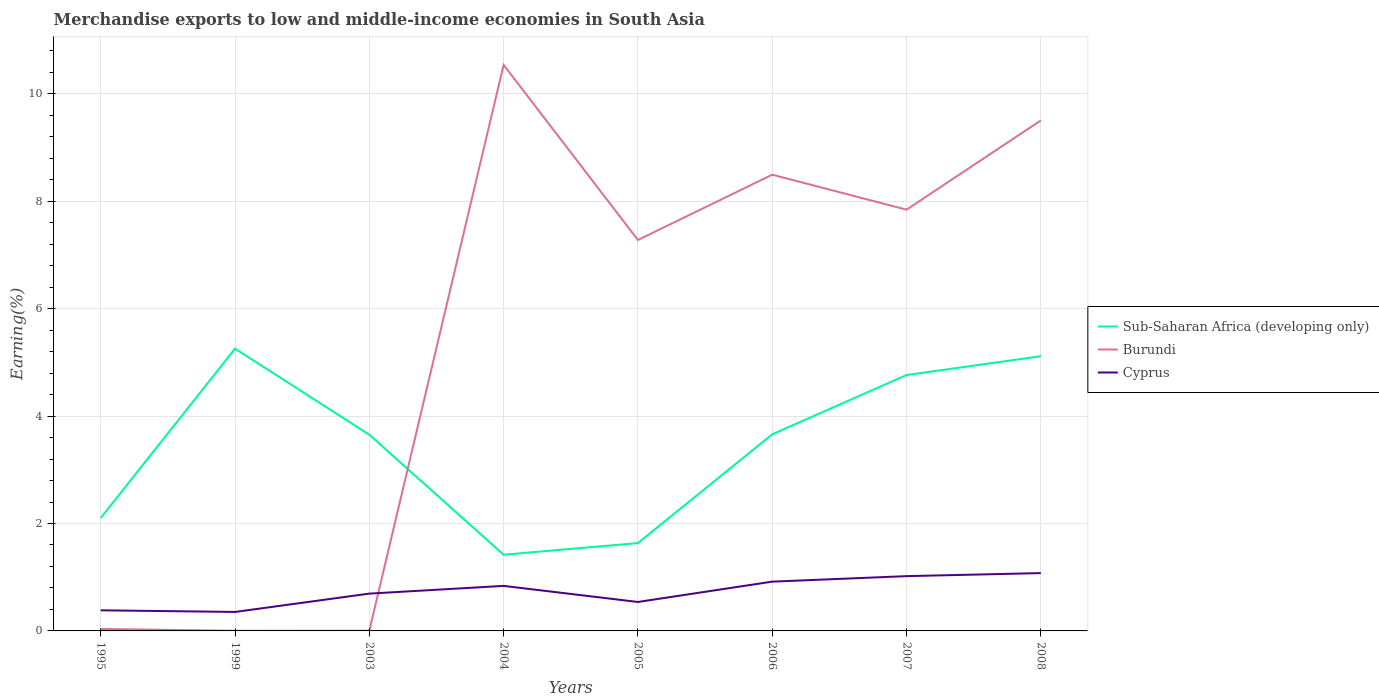How many different coloured lines are there?
Give a very brief answer. 3. Is the number of lines equal to the number of legend labels?
Ensure brevity in your answer.  Yes. Across all years, what is the maximum percentage of amount earned from merchandise exports in Cyprus?
Your answer should be compact. 0.35. In which year was the percentage of amount earned from merchandise exports in Burundi maximum?
Give a very brief answer. 1999. What is the total percentage of amount earned from merchandise exports in Cyprus in the graph?
Your response must be concise. -0.08. What is the difference between the highest and the second highest percentage of amount earned from merchandise exports in Sub-Saharan Africa (developing only)?
Your answer should be very brief. 3.84. How many lines are there?
Give a very brief answer. 3. How many years are there in the graph?
Offer a very short reply. 8. Are the values on the major ticks of Y-axis written in scientific E-notation?
Provide a succinct answer. No. Where does the legend appear in the graph?
Ensure brevity in your answer.  Center right. How many legend labels are there?
Ensure brevity in your answer.  3. How are the legend labels stacked?
Ensure brevity in your answer.  Vertical. What is the title of the graph?
Offer a very short reply. Merchandise exports to low and middle-income economies in South Asia. Does "World" appear as one of the legend labels in the graph?
Your answer should be compact. No. What is the label or title of the X-axis?
Provide a succinct answer. Years. What is the label or title of the Y-axis?
Offer a terse response. Earning(%). What is the Earning(%) in Sub-Saharan Africa (developing only) in 1995?
Your answer should be very brief. 2.1. What is the Earning(%) of Burundi in 1995?
Give a very brief answer. 0.04. What is the Earning(%) in Cyprus in 1995?
Ensure brevity in your answer.  0.38. What is the Earning(%) in Sub-Saharan Africa (developing only) in 1999?
Your response must be concise. 5.26. What is the Earning(%) in Burundi in 1999?
Give a very brief answer. 0. What is the Earning(%) in Cyprus in 1999?
Your answer should be compact. 0.35. What is the Earning(%) in Sub-Saharan Africa (developing only) in 2003?
Offer a terse response. 3.65. What is the Earning(%) of Burundi in 2003?
Give a very brief answer. 0. What is the Earning(%) of Cyprus in 2003?
Provide a short and direct response. 0.69. What is the Earning(%) in Sub-Saharan Africa (developing only) in 2004?
Give a very brief answer. 1.42. What is the Earning(%) of Burundi in 2004?
Keep it short and to the point. 10.54. What is the Earning(%) in Cyprus in 2004?
Your response must be concise. 0.84. What is the Earning(%) of Sub-Saharan Africa (developing only) in 2005?
Provide a short and direct response. 1.64. What is the Earning(%) of Burundi in 2005?
Your response must be concise. 7.28. What is the Earning(%) in Cyprus in 2005?
Your answer should be very brief. 0.54. What is the Earning(%) in Sub-Saharan Africa (developing only) in 2006?
Your response must be concise. 3.66. What is the Earning(%) in Burundi in 2006?
Make the answer very short. 8.49. What is the Earning(%) in Cyprus in 2006?
Your response must be concise. 0.92. What is the Earning(%) in Sub-Saharan Africa (developing only) in 2007?
Your response must be concise. 4.76. What is the Earning(%) of Burundi in 2007?
Offer a very short reply. 7.84. What is the Earning(%) of Cyprus in 2007?
Provide a succinct answer. 1.02. What is the Earning(%) of Sub-Saharan Africa (developing only) in 2008?
Keep it short and to the point. 5.11. What is the Earning(%) of Burundi in 2008?
Provide a short and direct response. 9.5. What is the Earning(%) of Cyprus in 2008?
Keep it short and to the point. 1.08. Across all years, what is the maximum Earning(%) in Sub-Saharan Africa (developing only)?
Provide a succinct answer. 5.26. Across all years, what is the maximum Earning(%) of Burundi?
Keep it short and to the point. 10.54. Across all years, what is the maximum Earning(%) in Cyprus?
Your response must be concise. 1.08. Across all years, what is the minimum Earning(%) of Sub-Saharan Africa (developing only)?
Your answer should be very brief. 1.42. Across all years, what is the minimum Earning(%) of Burundi?
Make the answer very short. 0. Across all years, what is the minimum Earning(%) in Cyprus?
Offer a very short reply. 0.35. What is the total Earning(%) in Sub-Saharan Africa (developing only) in the graph?
Ensure brevity in your answer.  27.6. What is the total Earning(%) of Burundi in the graph?
Keep it short and to the point. 43.7. What is the total Earning(%) of Cyprus in the graph?
Your answer should be compact. 5.82. What is the difference between the Earning(%) of Sub-Saharan Africa (developing only) in 1995 and that in 1999?
Your response must be concise. -3.15. What is the difference between the Earning(%) in Burundi in 1995 and that in 1999?
Make the answer very short. 0.03. What is the difference between the Earning(%) in Cyprus in 1995 and that in 1999?
Provide a short and direct response. 0.03. What is the difference between the Earning(%) of Sub-Saharan Africa (developing only) in 1995 and that in 2003?
Offer a terse response. -1.55. What is the difference between the Earning(%) in Burundi in 1995 and that in 2003?
Provide a short and direct response. 0.03. What is the difference between the Earning(%) of Cyprus in 1995 and that in 2003?
Give a very brief answer. -0.31. What is the difference between the Earning(%) of Sub-Saharan Africa (developing only) in 1995 and that in 2004?
Provide a succinct answer. 0.68. What is the difference between the Earning(%) of Burundi in 1995 and that in 2004?
Make the answer very short. -10.5. What is the difference between the Earning(%) of Cyprus in 1995 and that in 2004?
Your answer should be compact. -0.45. What is the difference between the Earning(%) of Sub-Saharan Africa (developing only) in 1995 and that in 2005?
Make the answer very short. 0.47. What is the difference between the Earning(%) of Burundi in 1995 and that in 2005?
Ensure brevity in your answer.  -7.24. What is the difference between the Earning(%) of Cyprus in 1995 and that in 2005?
Give a very brief answer. -0.16. What is the difference between the Earning(%) of Sub-Saharan Africa (developing only) in 1995 and that in 2006?
Provide a short and direct response. -1.56. What is the difference between the Earning(%) in Burundi in 1995 and that in 2006?
Provide a short and direct response. -8.46. What is the difference between the Earning(%) in Cyprus in 1995 and that in 2006?
Provide a succinct answer. -0.53. What is the difference between the Earning(%) in Sub-Saharan Africa (developing only) in 1995 and that in 2007?
Your answer should be compact. -2.66. What is the difference between the Earning(%) of Burundi in 1995 and that in 2007?
Ensure brevity in your answer.  -7.81. What is the difference between the Earning(%) of Cyprus in 1995 and that in 2007?
Your answer should be very brief. -0.64. What is the difference between the Earning(%) of Sub-Saharan Africa (developing only) in 1995 and that in 2008?
Keep it short and to the point. -3.01. What is the difference between the Earning(%) in Burundi in 1995 and that in 2008?
Your answer should be compact. -9.47. What is the difference between the Earning(%) in Cyprus in 1995 and that in 2008?
Offer a very short reply. -0.69. What is the difference between the Earning(%) in Sub-Saharan Africa (developing only) in 1999 and that in 2003?
Your response must be concise. 1.6. What is the difference between the Earning(%) in Burundi in 1999 and that in 2003?
Offer a terse response. -0. What is the difference between the Earning(%) in Cyprus in 1999 and that in 2003?
Keep it short and to the point. -0.34. What is the difference between the Earning(%) of Sub-Saharan Africa (developing only) in 1999 and that in 2004?
Provide a succinct answer. 3.84. What is the difference between the Earning(%) in Burundi in 1999 and that in 2004?
Your answer should be very brief. -10.54. What is the difference between the Earning(%) of Cyprus in 1999 and that in 2004?
Provide a short and direct response. -0.48. What is the difference between the Earning(%) of Sub-Saharan Africa (developing only) in 1999 and that in 2005?
Your answer should be compact. 3.62. What is the difference between the Earning(%) of Burundi in 1999 and that in 2005?
Provide a short and direct response. -7.28. What is the difference between the Earning(%) in Cyprus in 1999 and that in 2005?
Your answer should be compact. -0.19. What is the difference between the Earning(%) in Sub-Saharan Africa (developing only) in 1999 and that in 2006?
Your answer should be very brief. 1.6. What is the difference between the Earning(%) in Burundi in 1999 and that in 2006?
Provide a short and direct response. -8.49. What is the difference between the Earning(%) in Cyprus in 1999 and that in 2006?
Your response must be concise. -0.56. What is the difference between the Earning(%) of Sub-Saharan Africa (developing only) in 1999 and that in 2007?
Give a very brief answer. 0.49. What is the difference between the Earning(%) in Burundi in 1999 and that in 2007?
Keep it short and to the point. -7.84. What is the difference between the Earning(%) in Cyprus in 1999 and that in 2007?
Offer a very short reply. -0.67. What is the difference between the Earning(%) of Sub-Saharan Africa (developing only) in 1999 and that in 2008?
Provide a short and direct response. 0.14. What is the difference between the Earning(%) of Burundi in 1999 and that in 2008?
Provide a short and direct response. -9.5. What is the difference between the Earning(%) in Cyprus in 1999 and that in 2008?
Provide a succinct answer. -0.72. What is the difference between the Earning(%) of Sub-Saharan Africa (developing only) in 2003 and that in 2004?
Make the answer very short. 2.23. What is the difference between the Earning(%) in Burundi in 2003 and that in 2004?
Give a very brief answer. -10.53. What is the difference between the Earning(%) in Cyprus in 2003 and that in 2004?
Provide a short and direct response. -0.14. What is the difference between the Earning(%) of Sub-Saharan Africa (developing only) in 2003 and that in 2005?
Offer a terse response. 2.02. What is the difference between the Earning(%) in Burundi in 2003 and that in 2005?
Provide a short and direct response. -7.27. What is the difference between the Earning(%) in Cyprus in 2003 and that in 2005?
Offer a terse response. 0.16. What is the difference between the Earning(%) of Sub-Saharan Africa (developing only) in 2003 and that in 2006?
Give a very brief answer. -0.01. What is the difference between the Earning(%) in Burundi in 2003 and that in 2006?
Give a very brief answer. -8.49. What is the difference between the Earning(%) of Cyprus in 2003 and that in 2006?
Your answer should be very brief. -0.22. What is the difference between the Earning(%) of Sub-Saharan Africa (developing only) in 2003 and that in 2007?
Keep it short and to the point. -1.11. What is the difference between the Earning(%) of Burundi in 2003 and that in 2007?
Provide a succinct answer. -7.84. What is the difference between the Earning(%) of Cyprus in 2003 and that in 2007?
Offer a very short reply. -0.33. What is the difference between the Earning(%) of Sub-Saharan Africa (developing only) in 2003 and that in 2008?
Offer a very short reply. -1.46. What is the difference between the Earning(%) of Burundi in 2003 and that in 2008?
Keep it short and to the point. -9.5. What is the difference between the Earning(%) of Cyprus in 2003 and that in 2008?
Make the answer very short. -0.38. What is the difference between the Earning(%) in Sub-Saharan Africa (developing only) in 2004 and that in 2005?
Your answer should be compact. -0.22. What is the difference between the Earning(%) in Burundi in 2004 and that in 2005?
Make the answer very short. 3.26. What is the difference between the Earning(%) in Cyprus in 2004 and that in 2005?
Provide a short and direct response. 0.3. What is the difference between the Earning(%) in Sub-Saharan Africa (developing only) in 2004 and that in 2006?
Your answer should be compact. -2.24. What is the difference between the Earning(%) of Burundi in 2004 and that in 2006?
Make the answer very short. 2.04. What is the difference between the Earning(%) of Cyprus in 2004 and that in 2006?
Offer a terse response. -0.08. What is the difference between the Earning(%) of Sub-Saharan Africa (developing only) in 2004 and that in 2007?
Keep it short and to the point. -3.35. What is the difference between the Earning(%) of Burundi in 2004 and that in 2007?
Ensure brevity in your answer.  2.7. What is the difference between the Earning(%) in Cyprus in 2004 and that in 2007?
Your response must be concise. -0.18. What is the difference between the Earning(%) in Sub-Saharan Africa (developing only) in 2004 and that in 2008?
Your answer should be compact. -3.7. What is the difference between the Earning(%) of Burundi in 2004 and that in 2008?
Your response must be concise. 1.03. What is the difference between the Earning(%) in Cyprus in 2004 and that in 2008?
Make the answer very short. -0.24. What is the difference between the Earning(%) in Sub-Saharan Africa (developing only) in 2005 and that in 2006?
Your answer should be compact. -2.02. What is the difference between the Earning(%) in Burundi in 2005 and that in 2006?
Make the answer very short. -1.22. What is the difference between the Earning(%) in Cyprus in 2005 and that in 2006?
Make the answer very short. -0.38. What is the difference between the Earning(%) of Sub-Saharan Africa (developing only) in 2005 and that in 2007?
Provide a succinct answer. -3.13. What is the difference between the Earning(%) in Burundi in 2005 and that in 2007?
Keep it short and to the point. -0.56. What is the difference between the Earning(%) in Cyprus in 2005 and that in 2007?
Provide a succinct answer. -0.48. What is the difference between the Earning(%) in Sub-Saharan Africa (developing only) in 2005 and that in 2008?
Keep it short and to the point. -3.48. What is the difference between the Earning(%) in Burundi in 2005 and that in 2008?
Offer a very short reply. -2.23. What is the difference between the Earning(%) of Cyprus in 2005 and that in 2008?
Ensure brevity in your answer.  -0.54. What is the difference between the Earning(%) of Sub-Saharan Africa (developing only) in 2006 and that in 2007?
Your answer should be compact. -1.1. What is the difference between the Earning(%) of Burundi in 2006 and that in 2007?
Your response must be concise. 0.65. What is the difference between the Earning(%) in Cyprus in 2006 and that in 2007?
Make the answer very short. -0.1. What is the difference between the Earning(%) of Sub-Saharan Africa (developing only) in 2006 and that in 2008?
Offer a very short reply. -1.45. What is the difference between the Earning(%) of Burundi in 2006 and that in 2008?
Provide a succinct answer. -1.01. What is the difference between the Earning(%) in Cyprus in 2006 and that in 2008?
Your response must be concise. -0.16. What is the difference between the Earning(%) in Sub-Saharan Africa (developing only) in 2007 and that in 2008?
Your answer should be compact. -0.35. What is the difference between the Earning(%) in Burundi in 2007 and that in 2008?
Your response must be concise. -1.66. What is the difference between the Earning(%) in Cyprus in 2007 and that in 2008?
Ensure brevity in your answer.  -0.06. What is the difference between the Earning(%) of Sub-Saharan Africa (developing only) in 1995 and the Earning(%) of Burundi in 1999?
Offer a very short reply. 2.1. What is the difference between the Earning(%) in Sub-Saharan Africa (developing only) in 1995 and the Earning(%) in Cyprus in 1999?
Provide a succinct answer. 1.75. What is the difference between the Earning(%) of Burundi in 1995 and the Earning(%) of Cyprus in 1999?
Ensure brevity in your answer.  -0.32. What is the difference between the Earning(%) of Sub-Saharan Africa (developing only) in 1995 and the Earning(%) of Burundi in 2003?
Your response must be concise. 2.1. What is the difference between the Earning(%) of Sub-Saharan Africa (developing only) in 1995 and the Earning(%) of Cyprus in 2003?
Your answer should be compact. 1.41. What is the difference between the Earning(%) of Burundi in 1995 and the Earning(%) of Cyprus in 2003?
Offer a very short reply. -0.66. What is the difference between the Earning(%) of Sub-Saharan Africa (developing only) in 1995 and the Earning(%) of Burundi in 2004?
Provide a succinct answer. -8.44. What is the difference between the Earning(%) in Sub-Saharan Africa (developing only) in 1995 and the Earning(%) in Cyprus in 2004?
Your answer should be very brief. 1.26. What is the difference between the Earning(%) of Burundi in 1995 and the Earning(%) of Cyprus in 2004?
Your answer should be very brief. -0.8. What is the difference between the Earning(%) of Sub-Saharan Africa (developing only) in 1995 and the Earning(%) of Burundi in 2005?
Offer a very short reply. -5.18. What is the difference between the Earning(%) of Sub-Saharan Africa (developing only) in 1995 and the Earning(%) of Cyprus in 2005?
Offer a terse response. 1.56. What is the difference between the Earning(%) in Burundi in 1995 and the Earning(%) in Cyprus in 2005?
Keep it short and to the point. -0.5. What is the difference between the Earning(%) of Sub-Saharan Africa (developing only) in 1995 and the Earning(%) of Burundi in 2006?
Give a very brief answer. -6.39. What is the difference between the Earning(%) of Sub-Saharan Africa (developing only) in 1995 and the Earning(%) of Cyprus in 2006?
Your answer should be compact. 1.18. What is the difference between the Earning(%) in Burundi in 1995 and the Earning(%) in Cyprus in 2006?
Keep it short and to the point. -0.88. What is the difference between the Earning(%) of Sub-Saharan Africa (developing only) in 1995 and the Earning(%) of Burundi in 2007?
Offer a terse response. -5.74. What is the difference between the Earning(%) in Sub-Saharan Africa (developing only) in 1995 and the Earning(%) in Cyprus in 2007?
Your answer should be very brief. 1.08. What is the difference between the Earning(%) in Burundi in 1995 and the Earning(%) in Cyprus in 2007?
Keep it short and to the point. -0.98. What is the difference between the Earning(%) of Sub-Saharan Africa (developing only) in 1995 and the Earning(%) of Burundi in 2008?
Offer a very short reply. -7.4. What is the difference between the Earning(%) of Sub-Saharan Africa (developing only) in 1995 and the Earning(%) of Cyprus in 2008?
Your response must be concise. 1.03. What is the difference between the Earning(%) in Burundi in 1995 and the Earning(%) in Cyprus in 2008?
Give a very brief answer. -1.04. What is the difference between the Earning(%) of Sub-Saharan Africa (developing only) in 1999 and the Earning(%) of Burundi in 2003?
Give a very brief answer. 5.25. What is the difference between the Earning(%) of Sub-Saharan Africa (developing only) in 1999 and the Earning(%) of Cyprus in 2003?
Offer a very short reply. 4.56. What is the difference between the Earning(%) in Burundi in 1999 and the Earning(%) in Cyprus in 2003?
Offer a very short reply. -0.69. What is the difference between the Earning(%) in Sub-Saharan Africa (developing only) in 1999 and the Earning(%) in Burundi in 2004?
Give a very brief answer. -5.28. What is the difference between the Earning(%) of Sub-Saharan Africa (developing only) in 1999 and the Earning(%) of Cyprus in 2004?
Offer a terse response. 4.42. What is the difference between the Earning(%) of Burundi in 1999 and the Earning(%) of Cyprus in 2004?
Offer a terse response. -0.84. What is the difference between the Earning(%) of Sub-Saharan Africa (developing only) in 1999 and the Earning(%) of Burundi in 2005?
Provide a short and direct response. -2.02. What is the difference between the Earning(%) in Sub-Saharan Africa (developing only) in 1999 and the Earning(%) in Cyprus in 2005?
Provide a short and direct response. 4.72. What is the difference between the Earning(%) in Burundi in 1999 and the Earning(%) in Cyprus in 2005?
Offer a terse response. -0.54. What is the difference between the Earning(%) of Sub-Saharan Africa (developing only) in 1999 and the Earning(%) of Burundi in 2006?
Provide a succinct answer. -3.24. What is the difference between the Earning(%) of Sub-Saharan Africa (developing only) in 1999 and the Earning(%) of Cyprus in 2006?
Ensure brevity in your answer.  4.34. What is the difference between the Earning(%) of Burundi in 1999 and the Earning(%) of Cyprus in 2006?
Give a very brief answer. -0.91. What is the difference between the Earning(%) of Sub-Saharan Africa (developing only) in 1999 and the Earning(%) of Burundi in 2007?
Provide a succinct answer. -2.59. What is the difference between the Earning(%) in Sub-Saharan Africa (developing only) in 1999 and the Earning(%) in Cyprus in 2007?
Provide a short and direct response. 4.24. What is the difference between the Earning(%) in Burundi in 1999 and the Earning(%) in Cyprus in 2007?
Ensure brevity in your answer.  -1.02. What is the difference between the Earning(%) in Sub-Saharan Africa (developing only) in 1999 and the Earning(%) in Burundi in 2008?
Provide a short and direct response. -4.25. What is the difference between the Earning(%) of Sub-Saharan Africa (developing only) in 1999 and the Earning(%) of Cyprus in 2008?
Ensure brevity in your answer.  4.18. What is the difference between the Earning(%) of Burundi in 1999 and the Earning(%) of Cyprus in 2008?
Provide a short and direct response. -1.07. What is the difference between the Earning(%) of Sub-Saharan Africa (developing only) in 2003 and the Earning(%) of Burundi in 2004?
Your answer should be compact. -6.89. What is the difference between the Earning(%) in Sub-Saharan Africa (developing only) in 2003 and the Earning(%) in Cyprus in 2004?
Provide a short and direct response. 2.81. What is the difference between the Earning(%) in Burundi in 2003 and the Earning(%) in Cyprus in 2004?
Your response must be concise. -0.83. What is the difference between the Earning(%) in Sub-Saharan Africa (developing only) in 2003 and the Earning(%) in Burundi in 2005?
Offer a terse response. -3.63. What is the difference between the Earning(%) of Sub-Saharan Africa (developing only) in 2003 and the Earning(%) of Cyprus in 2005?
Ensure brevity in your answer.  3.11. What is the difference between the Earning(%) in Burundi in 2003 and the Earning(%) in Cyprus in 2005?
Your answer should be compact. -0.53. What is the difference between the Earning(%) of Sub-Saharan Africa (developing only) in 2003 and the Earning(%) of Burundi in 2006?
Ensure brevity in your answer.  -4.84. What is the difference between the Earning(%) in Sub-Saharan Africa (developing only) in 2003 and the Earning(%) in Cyprus in 2006?
Your response must be concise. 2.73. What is the difference between the Earning(%) in Burundi in 2003 and the Earning(%) in Cyprus in 2006?
Offer a terse response. -0.91. What is the difference between the Earning(%) in Sub-Saharan Africa (developing only) in 2003 and the Earning(%) in Burundi in 2007?
Provide a succinct answer. -4.19. What is the difference between the Earning(%) of Sub-Saharan Africa (developing only) in 2003 and the Earning(%) of Cyprus in 2007?
Keep it short and to the point. 2.63. What is the difference between the Earning(%) of Burundi in 2003 and the Earning(%) of Cyprus in 2007?
Your response must be concise. -1.02. What is the difference between the Earning(%) in Sub-Saharan Africa (developing only) in 2003 and the Earning(%) in Burundi in 2008?
Ensure brevity in your answer.  -5.85. What is the difference between the Earning(%) in Sub-Saharan Africa (developing only) in 2003 and the Earning(%) in Cyprus in 2008?
Provide a succinct answer. 2.58. What is the difference between the Earning(%) in Burundi in 2003 and the Earning(%) in Cyprus in 2008?
Your answer should be compact. -1.07. What is the difference between the Earning(%) of Sub-Saharan Africa (developing only) in 2004 and the Earning(%) of Burundi in 2005?
Give a very brief answer. -5.86. What is the difference between the Earning(%) in Sub-Saharan Africa (developing only) in 2004 and the Earning(%) in Cyprus in 2005?
Your response must be concise. 0.88. What is the difference between the Earning(%) of Burundi in 2004 and the Earning(%) of Cyprus in 2005?
Provide a succinct answer. 10. What is the difference between the Earning(%) in Sub-Saharan Africa (developing only) in 2004 and the Earning(%) in Burundi in 2006?
Provide a short and direct response. -7.08. What is the difference between the Earning(%) of Sub-Saharan Africa (developing only) in 2004 and the Earning(%) of Cyprus in 2006?
Offer a terse response. 0.5. What is the difference between the Earning(%) of Burundi in 2004 and the Earning(%) of Cyprus in 2006?
Your response must be concise. 9.62. What is the difference between the Earning(%) of Sub-Saharan Africa (developing only) in 2004 and the Earning(%) of Burundi in 2007?
Keep it short and to the point. -6.42. What is the difference between the Earning(%) of Sub-Saharan Africa (developing only) in 2004 and the Earning(%) of Cyprus in 2007?
Offer a very short reply. 0.4. What is the difference between the Earning(%) of Burundi in 2004 and the Earning(%) of Cyprus in 2007?
Offer a terse response. 9.52. What is the difference between the Earning(%) of Sub-Saharan Africa (developing only) in 2004 and the Earning(%) of Burundi in 2008?
Your answer should be very brief. -8.09. What is the difference between the Earning(%) of Sub-Saharan Africa (developing only) in 2004 and the Earning(%) of Cyprus in 2008?
Your response must be concise. 0.34. What is the difference between the Earning(%) of Burundi in 2004 and the Earning(%) of Cyprus in 2008?
Offer a very short reply. 9.46. What is the difference between the Earning(%) of Sub-Saharan Africa (developing only) in 2005 and the Earning(%) of Burundi in 2006?
Provide a short and direct response. -6.86. What is the difference between the Earning(%) in Sub-Saharan Africa (developing only) in 2005 and the Earning(%) in Cyprus in 2006?
Ensure brevity in your answer.  0.72. What is the difference between the Earning(%) of Burundi in 2005 and the Earning(%) of Cyprus in 2006?
Offer a very short reply. 6.36. What is the difference between the Earning(%) of Sub-Saharan Africa (developing only) in 2005 and the Earning(%) of Burundi in 2007?
Your answer should be very brief. -6.21. What is the difference between the Earning(%) in Sub-Saharan Africa (developing only) in 2005 and the Earning(%) in Cyprus in 2007?
Offer a terse response. 0.62. What is the difference between the Earning(%) in Burundi in 2005 and the Earning(%) in Cyprus in 2007?
Offer a very short reply. 6.26. What is the difference between the Earning(%) of Sub-Saharan Africa (developing only) in 2005 and the Earning(%) of Burundi in 2008?
Provide a short and direct response. -7.87. What is the difference between the Earning(%) in Sub-Saharan Africa (developing only) in 2005 and the Earning(%) in Cyprus in 2008?
Offer a very short reply. 0.56. What is the difference between the Earning(%) in Burundi in 2005 and the Earning(%) in Cyprus in 2008?
Give a very brief answer. 6.2. What is the difference between the Earning(%) in Sub-Saharan Africa (developing only) in 2006 and the Earning(%) in Burundi in 2007?
Your answer should be very brief. -4.18. What is the difference between the Earning(%) in Sub-Saharan Africa (developing only) in 2006 and the Earning(%) in Cyprus in 2007?
Provide a succinct answer. 2.64. What is the difference between the Earning(%) in Burundi in 2006 and the Earning(%) in Cyprus in 2007?
Your answer should be compact. 7.47. What is the difference between the Earning(%) in Sub-Saharan Africa (developing only) in 2006 and the Earning(%) in Burundi in 2008?
Your answer should be compact. -5.84. What is the difference between the Earning(%) in Sub-Saharan Africa (developing only) in 2006 and the Earning(%) in Cyprus in 2008?
Provide a succinct answer. 2.58. What is the difference between the Earning(%) of Burundi in 2006 and the Earning(%) of Cyprus in 2008?
Your response must be concise. 7.42. What is the difference between the Earning(%) in Sub-Saharan Africa (developing only) in 2007 and the Earning(%) in Burundi in 2008?
Your answer should be very brief. -4.74. What is the difference between the Earning(%) in Sub-Saharan Africa (developing only) in 2007 and the Earning(%) in Cyprus in 2008?
Give a very brief answer. 3.69. What is the difference between the Earning(%) of Burundi in 2007 and the Earning(%) of Cyprus in 2008?
Ensure brevity in your answer.  6.77. What is the average Earning(%) of Sub-Saharan Africa (developing only) per year?
Give a very brief answer. 3.45. What is the average Earning(%) in Burundi per year?
Offer a terse response. 5.46. What is the average Earning(%) of Cyprus per year?
Provide a short and direct response. 0.73. In the year 1995, what is the difference between the Earning(%) in Sub-Saharan Africa (developing only) and Earning(%) in Burundi?
Offer a terse response. 2.07. In the year 1995, what is the difference between the Earning(%) of Sub-Saharan Africa (developing only) and Earning(%) of Cyprus?
Offer a terse response. 1.72. In the year 1995, what is the difference between the Earning(%) in Burundi and Earning(%) in Cyprus?
Your answer should be very brief. -0.35. In the year 1999, what is the difference between the Earning(%) in Sub-Saharan Africa (developing only) and Earning(%) in Burundi?
Offer a terse response. 5.25. In the year 1999, what is the difference between the Earning(%) in Sub-Saharan Africa (developing only) and Earning(%) in Cyprus?
Your response must be concise. 4.9. In the year 1999, what is the difference between the Earning(%) in Burundi and Earning(%) in Cyprus?
Offer a terse response. -0.35. In the year 2003, what is the difference between the Earning(%) in Sub-Saharan Africa (developing only) and Earning(%) in Burundi?
Provide a short and direct response. 3.65. In the year 2003, what is the difference between the Earning(%) of Sub-Saharan Africa (developing only) and Earning(%) of Cyprus?
Your answer should be compact. 2.96. In the year 2003, what is the difference between the Earning(%) of Burundi and Earning(%) of Cyprus?
Keep it short and to the point. -0.69. In the year 2004, what is the difference between the Earning(%) of Sub-Saharan Africa (developing only) and Earning(%) of Burundi?
Keep it short and to the point. -9.12. In the year 2004, what is the difference between the Earning(%) of Sub-Saharan Africa (developing only) and Earning(%) of Cyprus?
Provide a succinct answer. 0.58. In the year 2004, what is the difference between the Earning(%) in Burundi and Earning(%) in Cyprus?
Provide a succinct answer. 9.7. In the year 2005, what is the difference between the Earning(%) of Sub-Saharan Africa (developing only) and Earning(%) of Burundi?
Make the answer very short. -5.64. In the year 2005, what is the difference between the Earning(%) of Sub-Saharan Africa (developing only) and Earning(%) of Cyprus?
Offer a very short reply. 1.1. In the year 2005, what is the difference between the Earning(%) of Burundi and Earning(%) of Cyprus?
Ensure brevity in your answer.  6.74. In the year 2006, what is the difference between the Earning(%) of Sub-Saharan Africa (developing only) and Earning(%) of Burundi?
Offer a terse response. -4.83. In the year 2006, what is the difference between the Earning(%) in Sub-Saharan Africa (developing only) and Earning(%) in Cyprus?
Your answer should be compact. 2.74. In the year 2006, what is the difference between the Earning(%) in Burundi and Earning(%) in Cyprus?
Your answer should be compact. 7.58. In the year 2007, what is the difference between the Earning(%) of Sub-Saharan Africa (developing only) and Earning(%) of Burundi?
Your response must be concise. -3.08. In the year 2007, what is the difference between the Earning(%) of Sub-Saharan Africa (developing only) and Earning(%) of Cyprus?
Keep it short and to the point. 3.74. In the year 2007, what is the difference between the Earning(%) of Burundi and Earning(%) of Cyprus?
Your answer should be compact. 6.82. In the year 2008, what is the difference between the Earning(%) of Sub-Saharan Africa (developing only) and Earning(%) of Burundi?
Provide a succinct answer. -4.39. In the year 2008, what is the difference between the Earning(%) in Sub-Saharan Africa (developing only) and Earning(%) in Cyprus?
Give a very brief answer. 4.04. In the year 2008, what is the difference between the Earning(%) of Burundi and Earning(%) of Cyprus?
Ensure brevity in your answer.  8.43. What is the ratio of the Earning(%) in Burundi in 1995 to that in 1999?
Give a very brief answer. 14.3. What is the ratio of the Earning(%) of Cyprus in 1995 to that in 1999?
Give a very brief answer. 1.09. What is the ratio of the Earning(%) of Sub-Saharan Africa (developing only) in 1995 to that in 2003?
Make the answer very short. 0.58. What is the ratio of the Earning(%) of Burundi in 1995 to that in 2003?
Your answer should be compact. 8.83. What is the ratio of the Earning(%) of Cyprus in 1995 to that in 2003?
Ensure brevity in your answer.  0.55. What is the ratio of the Earning(%) in Sub-Saharan Africa (developing only) in 1995 to that in 2004?
Your response must be concise. 1.48. What is the ratio of the Earning(%) in Burundi in 1995 to that in 2004?
Give a very brief answer. 0. What is the ratio of the Earning(%) of Cyprus in 1995 to that in 2004?
Provide a succinct answer. 0.46. What is the ratio of the Earning(%) of Sub-Saharan Africa (developing only) in 1995 to that in 2005?
Ensure brevity in your answer.  1.29. What is the ratio of the Earning(%) in Burundi in 1995 to that in 2005?
Offer a very short reply. 0.01. What is the ratio of the Earning(%) of Cyprus in 1995 to that in 2005?
Provide a succinct answer. 0.71. What is the ratio of the Earning(%) of Sub-Saharan Africa (developing only) in 1995 to that in 2006?
Keep it short and to the point. 0.57. What is the ratio of the Earning(%) in Burundi in 1995 to that in 2006?
Give a very brief answer. 0. What is the ratio of the Earning(%) of Cyprus in 1995 to that in 2006?
Offer a very short reply. 0.42. What is the ratio of the Earning(%) in Sub-Saharan Africa (developing only) in 1995 to that in 2007?
Your answer should be very brief. 0.44. What is the ratio of the Earning(%) in Burundi in 1995 to that in 2007?
Your answer should be very brief. 0. What is the ratio of the Earning(%) in Cyprus in 1995 to that in 2007?
Your response must be concise. 0.38. What is the ratio of the Earning(%) of Sub-Saharan Africa (developing only) in 1995 to that in 2008?
Offer a terse response. 0.41. What is the ratio of the Earning(%) in Burundi in 1995 to that in 2008?
Offer a very short reply. 0. What is the ratio of the Earning(%) in Cyprus in 1995 to that in 2008?
Offer a terse response. 0.36. What is the ratio of the Earning(%) in Sub-Saharan Africa (developing only) in 1999 to that in 2003?
Keep it short and to the point. 1.44. What is the ratio of the Earning(%) in Burundi in 1999 to that in 2003?
Ensure brevity in your answer.  0.62. What is the ratio of the Earning(%) of Cyprus in 1999 to that in 2003?
Make the answer very short. 0.51. What is the ratio of the Earning(%) in Sub-Saharan Africa (developing only) in 1999 to that in 2004?
Your answer should be very brief. 3.7. What is the ratio of the Earning(%) of Cyprus in 1999 to that in 2004?
Keep it short and to the point. 0.42. What is the ratio of the Earning(%) in Sub-Saharan Africa (developing only) in 1999 to that in 2005?
Offer a very short reply. 3.21. What is the ratio of the Earning(%) in Cyprus in 1999 to that in 2005?
Ensure brevity in your answer.  0.66. What is the ratio of the Earning(%) of Sub-Saharan Africa (developing only) in 1999 to that in 2006?
Your response must be concise. 1.44. What is the ratio of the Earning(%) in Burundi in 1999 to that in 2006?
Make the answer very short. 0. What is the ratio of the Earning(%) in Cyprus in 1999 to that in 2006?
Offer a terse response. 0.39. What is the ratio of the Earning(%) in Sub-Saharan Africa (developing only) in 1999 to that in 2007?
Offer a terse response. 1.1. What is the ratio of the Earning(%) of Cyprus in 1999 to that in 2007?
Your response must be concise. 0.35. What is the ratio of the Earning(%) in Sub-Saharan Africa (developing only) in 1999 to that in 2008?
Offer a very short reply. 1.03. What is the ratio of the Earning(%) of Burundi in 1999 to that in 2008?
Make the answer very short. 0. What is the ratio of the Earning(%) in Cyprus in 1999 to that in 2008?
Offer a very short reply. 0.33. What is the ratio of the Earning(%) of Sub-Saharan Africa (developing only) in 2003 to that in 2004?
Provide a short and direct response. 2.57. What is the ratio of the Earning(%) of Cyprus in 2003 to that in 2004?
Provide a succinct answer. 0.83. What is the ratio of the Earning(%) of Sub-Saharan Africa (developing only) in 2003 to that in 2005?
Provide a succinct answer. 2.23. What is the ratio of the Earning(%) of Burundi in 2003 to that in 2005?
Your answer should be very brief. 0. What is the ratio of the Earning(%) of Cyprus in 2003 to that in 2005?
Provide a succinct answer. 1.29. What is the ratio of the Earning(%) of Cyprus in 2003 to that in 2006?
Offer a terse response. 0.76. What is the ratio of the Earning(%) in Sub-Saharan Africa (developing only) in 2003 to that in 2007?
Your answer should be very brief. 0.77. What is the ratio of the Earning(%) of Burundi in 2003 to that in 2007?
Ensure brevity in your answer.  0. What is the ratio of the Earning(%) of Cyprus in 2003 to that in 2007?
Keep it short and to the point. 0.68. What is the ratio of the Earning(%) of Sub-Saharan Africa (developing only) in 2003 to that in 2008?
Your answer should be compact. 0.71. What is the ratio of the Earning(%) in Burundi in 2003 to that in 2008?
Keep it short and to the point. 0. What is the ratio of the Earning(%) in Cyprus in 2003 to that in 2008?
Keep it short and to the point. 0.65. What is the ratio of the Earning(%) in Sub-Saharan Africa (developing only) in 2004 to that in 2005?
Offer a terse response. 0.87. What is the ratio of the Earning(%) in Burundi in 2004 to that in 2005?
Offer a very short reply. 1.45. What is the ratio of the Earning(%) in Cyprus in 2004 to that in 2005?
Offer a very short reply. 1.56. What is the ratio of the Earning(%) of Sub-Saharan Africa (developing only) in 2004 to that in 2006?
Give a very brief answer. 0.39. What is the ratio of the Earning(%) in Burundi in 2004 to that in 2006?
Provide a short and direct response. 1.24. What is the ratio of the Earning(%) of Cyprus in 2004 to that in 2006?
Make the answer very short. 0.91. What is the ratio of the Earning(%) of Sub-Saharan Africa (developing only) in 2004 to that in 2007?
Provide a succinct answer. 0.3. What is the ratio of the Earning(%) in Burundi in 2004 to that in 2007?
Your answer should be compact. 1.34. What is the ratio of the Earning(%) of Cyprus in 2004 to that in 2007?
Give a very brief answer. 0.82. What is the ratio of the Earning(%) in Sub-Saharan Africa (developing only) in 2004 to that in 2008?
Offer a very short reply. 0.28. What is the ratio of the Earning(%) of Burundi in 2004 to that in 2008?
Your answer should be very brief. 1.11. What is the ratio of the Earning(%) in Cyprus in 2004 to that in 2008?
Offer a terse response. 0.78. What is the ratio of the Earning(%) in Sub-Saharan Africa (developing only) in 2005 to that in 2006?
Offer a terse response. 0.45. What is the ratio of the Earning(%) of Burundi in 2005 to that in 2006?
Your response must be concise. 0.86. What is the ratio of the Earning(%) in Cyprus in 2005 to that in 2006?
Your answer should be compact. 0.59. What is the ratio of the Earning(%) in Sub-Saharan Africa (developing only) in 2005 to that in 2007?
Offer a terse response. 0.34. What is the ratio of the Earning(%) in Burundi in 2005 to that in 2007?
Your answer should be compact. 0.93. What is the ratio of the Earning(%) in Cyprus in 2005 to that in 2007?
Give a very brief answer. 0.53. What is the ratio of the Earning(%) of Sub-Saharan Africa (developing only) in 2005 to that in 2008?
Keep it short and to the point. 0.32. What is the ratio of the Earning(%) of Burundi in 2005 to that in 2008?
Provide a succinct answer. 0.77. What is the ratio of the Earning(%) of Cyprus in 2005 to that in 2008?
Your response must be concise. 0.5. What is the ratio of the Earning(%) of Sub-Saharan Africa (developing only) in 2006 to that in 2007?
Make the answer very short. 0.77. What is the ratio of the Earning(%) of Burundi in 2006 to that in 2007?
Your answer should be very brief. 1.08. What is the ratio of the Earning(%) in Cyprus in 2006 to that in 2007?
Offer a terse response. 0.9. What is the ratio of the Earning(%) of Sub-Saharan Africa (developing only) in 2006 to that in 2008?
Make the answer very short. 0.72. What is the ratio of the Earning(%) of Burundi in 2006 to that in 2008?
Make the answer very short. 0.89. What is the ratio of the Earning(%) in Cyprus in 2006 to that in 2008?
Ensure brevity in your answer.  0.85. What is the ratio of the Earning(%) of Sub-Saharan Africa (developing only) in 2007 to that in 2008?
Provide a short and direct response. 0.93. What is the ratio of the Earning(%) of Burundi in 2007 to that in 2008?
Make the answer very short. 0.83. What is the ratio of the Earning(%) in Cyprus in 2007 to that in 2008?
Your answer should be very brief. 0.95. What is the difference between the highest and the second highest Earning(%) in Sub-Saharan Africa (developing only)?
Provide a succinct answer. 0.14. What is the difference between the highest and the second highest Earning(%) in Burundi?
Give a very brief answer. 1.03. What is the difference between the highest and the second highest Earning(%) of Cyprus?
Give a very brief answer. 0.06. What is the difference between the highest and the lowest Earning(%) of Sub-Saharan Africa (developing only)?
Your answer should be compact. 3.84. What is the difference between the highest and the lowest Earning(%) of Burundi?
Keep it short and to the point. 10.54. What is the difference between the highest and the lowest Earning(%) of Cyprus?
Keep it short and to the point. 0.72. 